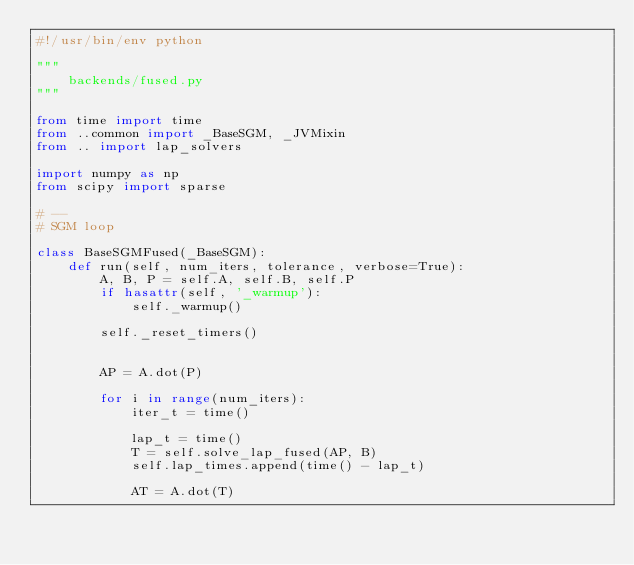<code> <loc_0><loc_0><loc_500><loc_500><_Python_>#!/usr/bin/env python

"""
    backends/fused.py
"""

from time import time
from ..common import _BaseSGM, _JVMixin
from .. import lap_solvers

import numpy as np
from scipy import sparse

# --
# SGM loop

class BaseSGMFused(_BaseSGM):
    def run(self, num_iters, tolerance, verbose=True):
        A, B, P = self.A, self.B, self.P
        if hasattr(self, '_warmup'):
            self._warmup()
        
        self._reset_timers()
        
        
        AP = A.dot(P)
        
        for i in range(num_iters):
            iter_t = time()
            
            lap_t = time()
            T = self.solve_lap_fused(AP, B)
            self.lap_times.append(time() - lap_t)
            
            AT = A.dot(T)
            </code> 